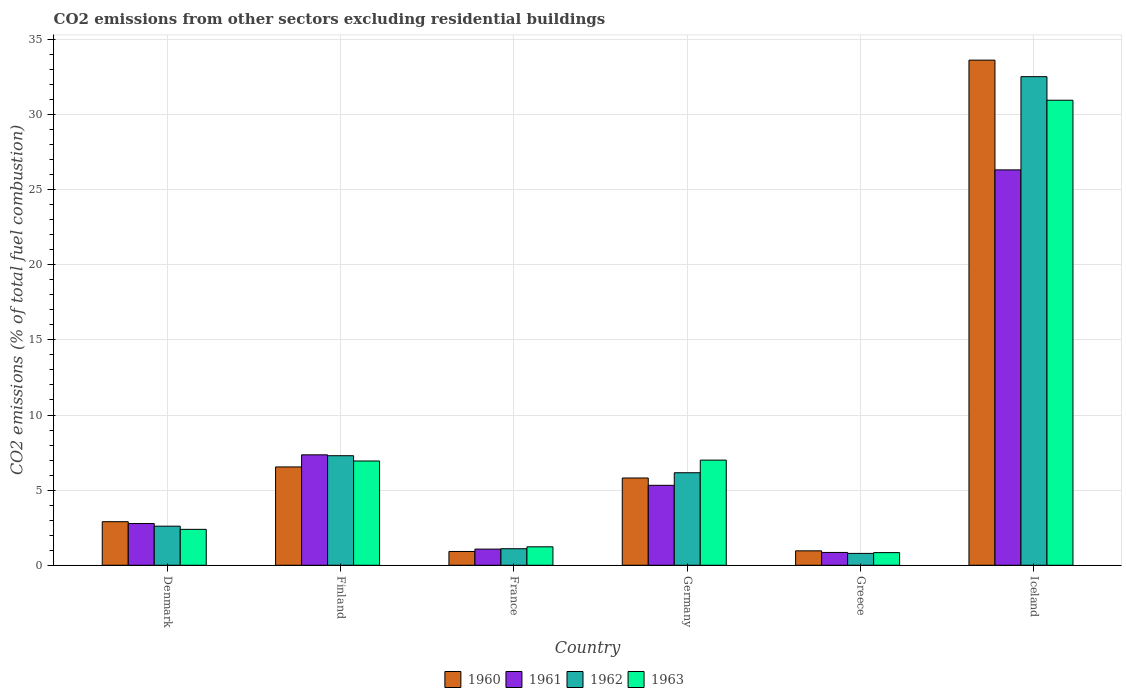How many different coloured bars are there?
Your answer should be very brief. 4. How many groups of bars are there?
Keep it short and to the point. 6. Are the number of bars on each tick of the X-axis equal?
Provide a succinct answer. Yes. How many bars are there on the 1st tick from the right?
Ensure brevity in your answer.  4. In how many cases, is the number of bars for a given country not equal to the number of legend labels?
Your response must be concise. 0. What is the total CO2 emitted in 1960 in Iceland?
Provide a succinct answer. 33.62. Across all countries, what is the maximum total CO2 emitted in 1961?
Make the answer very short. 26.32. Across all countries, what is the minimum total CO2 emitted in 1961?
Ensure brevity in your answer.  0.85. What is the total total CO2 emitted in 1963 in the graph?
Make the answer very short. 49.35. What is the difference between the total CO2 emitted in 1961 in Greece and that in Iceland?
Offer a terse response. -25.46. What is the difference between the total CO2 emitted in 1963 in Iceland and the total CO2 emitted in 1962 in Germany?
Give a very brief answer. 24.79. What is the average total CO2 emitted in 1961 per country?
Offer a terse response. 7.28. What is the difference between the total CO2 emitted of/in 1961 and total CO2 emitted of/in 1963 in France?
Ensure brevity in your answer.  -0.15. In how many countries, is the total CO2 emitted in 1961 greater than 1?
Your response must be concise. 5. What is the ratio of the total CO2 emitted in 1963 in Germany to that in Greece?
Provide a short and direct response. 8.32. Is the total CO2 emitted in 1962 in Germany less than that in Greece?
Offer a terse response. No. Is the difference between the total CO2 emitted in 1961 in Denmark and Finland greater than the difference between the total CO2 emitted in 1963 in Denmark and Finland?
Your answer should be very brief. No. What is the difference between the highest and the second highest total CO2 emitted in 1963?
Your response must be concise. -24.01. What is the difference between the highest and the lowest total CO2 emitted in 1963?
Provide a succinct answer. 30.11. Is it the case that in every country, the sum of the total CO2 emitted in 1961 and total CO2 emitted in 1960 is greater than the total CO2 emitted in 1962?
Ensure brevity in your answer.  Yes. Are all the bars in the graph horizontal?
Provide a short and direct response. No. How many countries are there in the graph?
Ensure brevity in your answer.  6. What is the difference between two consecutive major ticks on the Y-axis?
Your response must be concise. 5. Are the values on the major ticks of Y-axis written in scientific E-notation?
Keep it short and to the point. No. Does the graph contain grids?
Give a very brief answer. Yes. How are the legend labels stacked?
Your response must be concise. Horizontal. What is the title of the graph?
Keep it short and to the point. CO2 emissions from other sectors excluding residential buildings. What is the label or title of the X-axis?
Give a very brief answer. Country. What is the label or title of the Y-axis?
Make the answer very short. CO2 emissions (% of total fuel combustion). What is the CO2 emissions (% of total fuel combustion) of 1960 in Denmark?
Provide a succinct answer. 2.9. What is the CO2 emissions (% of total fuel combustion) in 1961 in Denmark?
Offer a terse response. 2.78. What is the CO2 emissions (% of total fuel combustion) in 1962 in Denmark?
Provide a short and direct response. 2.6. What is the CO2 emissions (% of total fuel combustion) of 1963 in Denmark?
Ensure brevity in your answer.  2.39. What is the CO2 emissions (% of total fuel combustion) in 1960 in Finland?
Provide a short and direct response. 6.54. What is the CO2 emissions (% of total fuel combustion) of 1961 in Finland?
Offer a terse response. 7.35. What is the CO2 emissions (% of total fuel combustion) of 1962 in Finland?
Offer a very short reply. 7.29. What is the CO2 emissions (% of total fuel combustion) in 1963 in Finland?
Your response must be concise. 6.94. What is the CO2 emissions (% of total fuel combustion) of 1960 in France?
Offer a terse response. 0.92. What is the CO2 emissions (% of total fuel combustion) in 1961 in France?
Provide a short and direct response. 1.08. What is the CO2 emissions (% of total fuel combustion) in 1962 in France?
Offer a terse response. 1.1. What is the CO2 emissions (% of total fuel combustion) in 1963 in France?
Your response must be concise. 1.23. What is the CO2 emissions (% of total fuel combustion) of 1960 in Germany?
Offer a terse response. 5.81. What is the CO2 emissions (% of total fuel combustion) in 1961 in Germany?
Ensure brevity in your answer.  5.32. What is the CO2 emissions (% of total fuel combustion) in 1962 in Germany?
Provide a succinct answer. 6.16. What is the CO2 emissions (% of total fuel combustion) of 1963 in Germany?
Your answer should be compact. 7. What is the CO2 emissions (% of total fuel combustion) in 1960 in Greece?
Provide a short and direct response. 0.96. What is the CO2 emissions (% of total fuel combustion) of 1961 in Greece?
Make the answer very short. 0.85. What is the CO2 emissions (% of total fuel combustion) of 1962 in Greece?
Your answer should be very brief. 0.79. What is the CO2 emissions (% of total fuel combustion) in 1963 in Greece?
Your answer should be compact. 0.84. What is the CO2 emissions (% of total fuel combustion) in 1960 in Iceland?
Your answer should be compact. 33.62. What is the CO2 emissions (% of total fuel combustion) in 1961 in Iceland?
Offer a very short reply. 26.32. What is the CO2 emissions (% of total fuel combustion) in 1962 in Iceland?
Provide a succinct answer. 32.52. What is the CO2 emissions (% of total fuel combustion) of 1963 in Iceland?
Your answer should be compact. 30.95. Across all countries, what is the maximum CO2 emissions (% of total fuel combustion) in 1960?
Provide a short and direct response. 33.62. Across all countries, what is the maximum CO2 emissions (% of total fuel combustion) in 1961?
Your response must be concise. 26.32. Across all countries, what is the maximum CO2 emissions (% of total fuel combustion) in 1962?
Make the answer very short. 32.52. Across all countries, what is the maximum CO2 emissions (% of total fuel combustion) in 1963?
Ensure brevity in your answer.  30.95. Across all countries, what is the minimum CO2 emissions (% of total fuel combustion) of 1960?
Ensure brevity in your answer.  0.92. Across all countries, what is the minimum CO2 emissions (% of total fuel combustion) in 1961?
Provide a short and direct response. 0.85. Across all countries, what is the minimum CO2 emissions (% of total fuel combustion) in 1962?
Ensure brevity in your answer.  0.79. Across all countries, what is the minimum CO2 emissions (% of total fuel combustion) of 1963?
Provide a succinct answer. 0.84. What is the total CO2 emissions (% of total fuel combustion) of 1960 in the graph?
Offer a very short reply. 50.75. What is the total CO2 emissions (% of total fuel combustion) in 1961 in the graph?
Provide a short and direct response. 43.69. What is the total CO2 emissions (% of total fuel combustion) of 1962 in the graph?
Give a very brief answer. 50.46. What is the total CO2 emissions (% of total fuel combustion) in 1963 in the graph?
Make the answer very short. 49.35. What is the difference between the CO2 emissions (% of total fuel combustion) in 1960 in Denmark and that in Finland?
Offer a very short reply. -3.64. What is the difference between the CO2 emissions (% of total fuel combustion) of 1961 in Denmark and that in Finland?
Your answer should be compact. -4.57. What is the difference between the CO2 emissions (% of total fuel combustion) of 1962 in Denmark and that in Finland?
Offer a terse response. -4.69. What is the difference between the CO2 emissions (% of total fuel combustion) of 1963 in Denmark and that in Finland?
Ensure brevity in your answer.  -4.55. What is the difference between the CO2 emissions (% of total fuel combustion) of 1960 in Denmark and that in France?
Provide a succinct answer. 1.98. What is the difference between the CO2 emissions (% of total fuel combustion) of 1961 in Denmark and that in France?
Provide a succinct answer. 1.7. What is the difference between the CO2 emissions (% of total fuel combustion) of 1962 in Denmark and that in France?
Ensure brevity in your answer.  1.5. What is the difference between the CO2 emissions (% of total fuel combustion) of 1963 in Denmark and that in France?
Offer a very short reply. 1.16. What is the difference between the CO2 emissions (% of total fuel combustion) in 1960 in Denmark and that in Germany?
Provide a succinct answer. -2.91. What is the difference between the CO2 emissions (% of total fuel combustion) of 1961 in Denmark and that in Germany?
Offer a terse response. -2.54. What is the difference between the CO2 emissions (% of total fuel combustion) of 1962 in Denmark and that in Germany?
Provide a succinct answer. -3.56. What is the difference between the CO2 emissions (% of total fuel combustion) of 1963 in Denmark and that in Germany?
Make the answer very short. -4.61. What is the difference between the CO2 emissions (% of total fuel combustion) of 1960 in Denmark and that in Greece?
Offer a terse response. 1.94. What is the difference between the CO2 emissions (% of total fuel combustion) of 1961 in Denmark and that in Greece?
Ensure brevity in your answer.  1.92. What is the difference between the CO2 emissions (% of total fuel combustion) of 1962 in Denmark and that in Greece?
Ensure brevity in your answer.  1.81. What is the difference between the CO2 emissions (% of total fuel combustion) of 1963 in Denmark and that in Greece?
Keep it short and to the point. 1.55. What is the difference between the CO2 emissions (% of total fuel combustion) of 1960 in Denmark and that in Iceland?
Your answer should be compact. -30.72. What is the difference between the CO2 emissions (% of total fuel combustion) of 1961 in Denmark and that in Iceland?
Give a very brief answer. -23.54. What is the difference between the CO2 emissions (% of total fuel combustion) of 1962 in Denmark and that in Iceland?
Keep it short and to the point. -29.92. What is the difference between the CO2 emissions (% of total fuel combustion) of 1963 in Denmark and that in Iceland?
Provide a succinct answer. -28.56. What is the difference between the CO2 emissions (% of total fuel combustion) of 1960 in Finland and that in France?
Your response must be concise. 5.63. What is the difference between the CO2 emissions (% of total fuel combustion) of 1961 in Finland and that in France?
Make the answer very short. 6.27. What is the difference between the CO2 emissions (% of total fuel combustion) of 1962 in Finland and that in France?
Your answer should be compact. 6.19. What is the difference between the CO2 emissions (% of total fuel combustion) in 1963 in Finland and that in France?
Provide a succinct answer. 5.71. What is the difference between the CO2 emissions (% of total fuel combustion) of 1960 in Finland and that in Germany?
Ensure brevity in your answer.  0.74. What is the difference between the CO2 emissions (% of total fuel combustion) of 1961 in Finland and that in Germany?
Give a very brief answer. 2.03. What is the difference between the CO2 emissions (% of total fuel combustion) in 1962 in Finland and that in Germany?
Offer a very short reply. 1.13. What is the difference between the CO2 emissions (% of total fuel combustion) of 1963 in Finland and that in Germany?
Give a very brief answer. -0.06. What is the difference between the CO2 emissions (% of total fuel combustion) in 1960 in Finland and that in Greece?
Provide a short and direct response. 5.58. What is the difference between the CO2 emissions (% of total fuel combustion) in 1961 in Finland and that in Greece?
Ensure brevity in your answer.  6.5. What is the difference between the CO2 emissions (% of total fuel combustion) in 1962 in Finland and that in Greece?
Provide a succinct answer. 6.5. What is the difference between the CO2 emissions (% of total fuel combustion) in 1963 in Finland and that in Greece?
Offer a very short reply. 6.1. What is the difference between the CO2 emissions (% of total fuel combustion) in 1960 in Finland and that in Iceland?
Your answer should be compact. -27.08. What is the difference between the CO2 emissions (% of total fuel combustion) of 1961 in Finland and that in Iceland?
Provide a short and direct response. -18.97. What is the difference between the CO2 emissions (% of total fuel combustion) of 1962 in Finland and that in Iceland?
Offer a terse response. -25.23. What is the difference between the CO2 emissions (% of total fuel combustion) of 1963 in Finland and that in Iceland?
Your answer should be very brief. -24.01. What is the difference between the CO2 emissions (% of total fuel combustion) in 1960 in France and that in Germany?
Offer a terse response. -4.89. What is the difference between the CO2 emissions (% of total fuel combustion) of 1961 in France and that in Germany?
Your response must be concise. -4.25. What is the difference between the CO2 emissions (% of total fuel combustion) in 1962 in France and that in Germany?
Ensure brevity in your answer.  -5.06. What is the difference between the CO2 emissions (% of total fuel combustion) of 1963 in France and that in Germany?
Provide a short and direct response. -5.77. What is the difference between the CO2 emissions (% of total fuel combustion) in 1960 in France and that in Greece?
Your response must be concise. -0.04. What is the difference between the CO2 emissions (% of total fuel combustion) of 1961 in France and that in Greece?
Provide a succinct answer. 0.22. What is the difference between the CO2 emissions (% of total fuel combustion) of 1962 in France and that in Greece?
Offer a very short reply. 0.31. What is the difference between the CO2 emissions (% of total fuel combustion) in 1963 in France and that in Greece?
Give a very brief answer. 0.39. What is the difference between the CO2 emissions (% of total fuel combustion) of 1960 in France and that in Iceland?
Give a very brief answer. -32.7. What is the difference between the CO2 emissions (% of total fuel combustion) in 1961 in France and that in Iceland?
Provide a succinct answer. -25.24. What is the difference between the CO2 emissions (% of total fuel combustion) of 1962 in France and that in Iceland?
Your answer should be very brief. -31.42. What is the difference between the CO2 emissions (% of total fuel combustion) in 1963 in France and that in Iceland?
Your answer should be compact. -29.73. What is the difference between the CO2 emissions (% of total fuel combustion) in 1960 in Germany and that in Greece?
Give a very brief answer. 4.85. What is the difference between the CO2 emissions (% of total fuel combustion) in 1961 in Germany and that in Greece?
Your answer should be very brief. 4.47. What is the difference between the CO2 emissions (% of total fuel combustion) of 1962 in Germany and that in Greece?
Your answer should be very brief. 5.37. What is the difference between the CO2 emissions (% of total fuel combustion) in 1963 in Germany and that in Greece?
Offer a terse response. 6.16. What is the difference between the CO2 emissions (% of total fuel combustion) of 1960 in Germany and that in Iceland?
Your response must be concise. -27.81. What is the difference between the CO2 emissions (% of total fuel combustion) of 1961 in Germany and that in Iceland?
Make the answer very short. -20.99. What is the difference between the CO2 emissions (% of total fuel combustion) in 1962 in Germany and that in Iceland?
Give a very brief answer. -26.36. What is the difference between the CO2 emissions (% of total fuel combustion) in 1963 in Germany and that in Iceland?
Keep it short and to the point. -23.95. What is the difference between the CO2 emissions (% of total fuel combustion) of 1960 in Greece and that in Iceland?
Keep it short and to the point. -32.66. What is the difference between the CO2 emissions (% of total fuel combustion) of 1961 in Greece and that in Iceland?
Offer a terse response. -25.46. What is the difference between the CO2 emissions (% of total fuel combustion) in 1962 in Greece and that in Iceland?
Provide a succinct answer. -31.73. What is the difference between the CO2 emissions (% of total fuel combustion) in 1963 in Greece and that in Iceland?
Your response must be concise. -30.11. What is the difference between the CO2 emissions (% of total fuel combustion) of 1960 in Denmark and the CO2 emissions (% of total fuel combustion) of 1961 in Finland?
Provide a short and direct response. -4.45. What is the difference between the CO2 emissions (% of total fuel combustion) of 1960 in Denmark and the CO2 emissions (% of total fuel combustion) of 1962 in Finland?
Your answer should be very brief. -4.39. What is the difference between the CO2 emissions (% of total fuel combustion) in 1960 in Denmark and the CO2 emissions (% of total fuel combustion) in 1963 in Finland?
Provide a succinct answer. -4.04. What is the difference between the CO2 emissions (% of total fuel combustion) in 1961 in Denmark and the CO2 emissions (% of total fuel combustion) in 1962 in Finland?
Provide a succinct answer. -4.51. What is the difference between the CO2 emissions (% of total fuel combustion) in 1961 in Denmark and the CO2 emissions (% of total fuel combustion) in 1963 in Finland?
Your answer should be compact. -4.16. What is the difference between the CO2 emissions (% of total fuel combustion) of 1962 in Denmark and the CO2 emissions (% of total fuel combustion) of 1963 in Finland?
Give a very brief answer. -4.34. What is the difference between the CO2 emissions (% of total fuel combustion) in 1960 in Denmark and the CO2 emissions (% of total fuel combustion) in 1961 in France?
Ensure brevity in your answer.  1.82. What is the difference between the CO2 emissions (% of total fuel combustion) in 1960 in Denmark and the CO2 emissions (% of total fuel combustion) in 1962 in France?
Ensure brevity in your answer.  1.8. What is the difference between the CO2 emissions (% of total fuel combustion) in 1960 in Denmark and the CO2 emissions (% of total fuel combustion) in 1963 in France?
Provide a short and direct response. 1.67. What is the difference between the CO2 emissions (% of total fuel combustion) of 1961 in Denmark and the CO2 emissions (% of total fuel combustion) of 1962 in France?
Your response must be concise. 1.68. What is the difference between the CO2 emissions (% of total fuel combustion) of 1961 in Denmark and the CO2 emissions (% of total fuel combustion) of 1963 in France?
Make the answer very short. 1.55. What is the difference between the CO2 emissions (% of total fuel combustion) of 1962 in Denmark and the CO2 emissions (% of total fuel combustion) of 1963 in France?
Your response must be concise. 1.37. What is the difference between the CO2 emissions (% of total fuel combustion) in 1960 in Denmark and the CO2 emissions (% of total fuel combustion) in 1961 in Germany?
Make the answer very short. -2.42. What is the difference between the CO2 emissions (% of total fuel combustion) in 1960 in Denmark and the CO2 emissions (% of total fuel combustion) in 1962 in Germany?
Your response must be concise. -3.26. What is the difference between the CO2 emissions (% of total fuel combustion) in 1960 in Denmark and the CO2 emissions (% of total fuel combustion) in 1963 in Germany?
Your answer should be compact. -4.1. What is the difference between the CO2 emissions (% of total fuel combustion) of 1961 in Denmark and the CO2 emissions (% of total fuel combustion) of 1962 in Germany?
Your answer should be very brief. -3.38. What is the difference between the CO2 emissions (% of total fuel combustion) in 1961 in Denmark and the CO2 emissions (% of total fuel combustion) in 1963 in Germany?
Provide a short and direct response. -4.22. What is the difference between the CO2 emissions (% of total fuel combustion) in 1962 in Denmark and the CO2 emissions (% of total fuel combustion) in 1963 in Germany?
Offer a very short reply. -4.4. What is the difference between the CO2 emissions (% of total fuel combustion) in 1960 in Denmark and the CO2 emissions (% of total fuel combustion) in 1961 in Greece?
Your answer should be compact. 2.05. What is the difference between the CO2 emissions (% of total fuel combustion) in 1960 in Denmark and the CO2 emissions (% of total fuel combustion) in 1962 in Greece?
Your answer should be very brief. 2.11. What is the difference between the CO2 emissions (% of total fuel combustion) of 1960 in Denmark and the CO2 emissions (% of total fuel combustion) of 1963 in Greece?
Offer a very short reply. 2.06. What is the difference between the CO2 emissions (% of total fuel combustion) in 1961 in Denmark and the CO2 emissions (% of total fuel combustion) in 1962 in Greece?
Provide a succinct answer. 1.99. What is the difference between the CO2 emissions (% of total fuel combustion) of 1961 in Denmark and the CO2 emissions (% of total fuel combustion) of 1963 in Greece?
Your response must be concise. 1.94. What is the difference between the CO2 emissions (% of total fuel combustion) in 1962 in Denmark and the CO2 emissions (% of total fuel combustion) in 1963 in Greece?
Provide a succinct answer. 1.76. What is the difference between the CO2 emissions (% of total fuel combustion) in 1960 in Denmark and the CO2 emissions (% of total fuel combustion) in 1961 in Iceland?
Your response must be concise. -23.42. What is the difference between the CO2 emissions (% of total fuel combustion) of 1960 in Denmark and the CO2 emissions (% of total fuel combustion) of 1962 in Iceland?
Keep it short and to the point. -29.62. What is the difference between the CO2 emissions (% of total fuel combustion) in 1960 in Denmark and the CO2 emissions (% of total fuel combustion) in 1963 in Iceland?
Provide a succinct answer. -28.05. What is the difference between the CO2 emissions (% of total fuel combustion) of 1961 in Denmark and the CO2 emissions (% of total fuel combustion) of 1962 in Iceland?
Provide a succinct answer. -29.74. What is the difference between the CO2 emissions (% of total fuel combustion) of 1961 in Denmark and the CO2 emissions (% of total fuel combustion) of 1963 in Iceland?
Provide a succinct answer. -28.18. What is the difference between the CO2 emissions (% of total fuel combustion) in 1962 in Denmark and the CO2 emissions (% of total fuel combustion) in 1963 in Iceland?
Ensure brevity in your answer.  -28.35. What is the difference between the CO2 emissions (% of total fuel combustion) of 1960 in Finland and the CO2 emissions (% of total fuel combustion) of 1961 in France?
Keep it short and to the point. 5.47. What is the difference between the CO2 emissions (% of total fuel combustion) in 1960 in Finland and the CO2 emissions (% of total fuel combustion) in 1962 in France?
Your response must be concise. 5.44. What is the difference between the CO2 emissions (% of total fuel combustion) in 1960 in Finland and the CO2 emissions (% of total fuel combustion) in 1963 in France?
Offer a very short reply. 5.32. What is the difference between the CO2 emissions (% of total fuel combustion) in 1961 in Finland and the CO2 emissions (% of total fuel combustion) in 1962 in France?
Your answer should be very brief. 6.25. What is the difference between the CO2 emissions (% of total fuel combustion) in 1961 in Finland and the CO2 emissions (% of total fuel combustion) in 1963 in France?
Ensure brevity in your answer.  6.12. What is the difference between the CO2 emissions (% of total fuel combustion) of 1962 in Finland and the CO2 emissions (% of total fuel combustion) of 1963 in France?
Your response must be concise. 6.06. What is the difference between the CO2 emissions (% of total fuel combustion) of 1960 in Finland and the CO2 emissions (% of total fuel combustion) of 1961 in Germany?
Give a very brief answer. 1.22. What is the difference between the CO2 emissions (% of total fuel combustion) in 1960 in Finland and the CO2 emissions (% of total fuel combustion) in 1962 in Germany?
Your response must be concise. 0.39. What is the difference between the CO2 emissions (% of total fuel combustion) in 1960 in Finland and the CO2 emissions (% of total fuel combustion) in 1963 in Germany?
Give a very brief answer. -0.45. What is the difference between the CO2 emissions (% of total fuel combustion) in 1961 in Finland and the CO2 emissions (% of total fuel combustion) in 1962 in Germany?
Offer a very short reply. 1.19. What is the difference between the CO2 emissions (% of total fuel combustion) of 1961 in Finland and the CO2 emissions (% of total fuel combustion) of 1963 in Germany?
Your answer should be compact. 0.35. What is the difference between the CO2 emissions (% of total fuel combustion) in 1962 in Finland and the CO2 emissions (% of total fuel combustion) in 1963 in Germany?
Your answer should be compact. 0.29. What is the difference between the CO2 emissions (% of total fuel combustion) of 1960 in Finland and the CO2 emissions (% of total fuel combustion) of 1961 in Greece?
Keep it short and to the point. 5.69. What is the difference between the CO2 emissions (% of total fuel combustion) in 1960 in Finland and the CO2 emissions (% of total fuel combustion) in 1962 in Greece?
Provide a short and direct response. 5.76. What is the difference between the CO2 emissions (% of total fuel combustion) in 1960 in Finland and the CO2 emissions (% of total fuel combustion) in 1963 in Greece?
Your answer should be very brief. 5.7. What is the difference between the CO2 emissions (% of total fuel combustion) in 1961 in Finland and the CO2 emissions (% of total fuel combustion) in 1962 in Greece?
Offer a terse response. 6.56. What is the difference between the CO2 emissions (% of total fuel combustion) in 1961 in Finland and the CO2 emissions (% of total fuel combustion) in 1963 in Greece?
Your answer should be compact. 6.51. What is the difference between the CO2 emissions (% of total fuel combustion) in 1962 in Finland and the CO2 emissions (% of total fuel combustion) in 1963 in Greece?
Ensure brevity in your answer.  6.45. What is the difference between the CO2 emissions (% of total fuel combustion) of 1960 in Finland and the CO2 emissions (% of total fuel combustion) of 1961 in Iceland?
Your answer should be compact. -19.77. What is the difference between the CO2 emissions (% of total fuel combustion) in 1960 in Finland and the CO2 emissions (% of total fuel combustion) in 1962 in Iceland?
Ensure brevity in your answer.  -25.98. What is the difference between the CO2 emissions (% of total fuel combustion) in 1960 in Finland and the CO2 emissions (% of total fuel combustion) in 1963 in Iceland?
Offer a terse response. -24.41. What is the difference between the CO2 emissions (% of total fuel combustion) of 1961 in Finland and the CO2 emissions (% of total fuel combustion) of 1962 in Iceland?
Make the answer very short. -25.17. What is the difference between the CO2 emissions (% of total fuel combustion) of 1961 in Finland and the CO2 emissions (% of total fuel combustion) of 1963 in Iceland?
Provide a short and direct response. -23.6. What is the difference between the CO2 emissions (% of total fuel combustion) of 1962 in Finland and the CO2 emissions (% of total fuel combustion) of 1963 in Iceland?
Your answer should be very brief. -23.66. What is the difference between the CO2 emissions (% of total fuel combustion) in 1960 in France and the CO2 emissions (% of total fuel combustion) in 1961 in Germany?
Offer a terse response. -4.4. What is the difference between the CO2 emissions (% of total fuel combustion) in 1960 in France and the CO2 emissions (% of total fuel combustion) in 1962 in Germany?
Provide a short and direct response. -5.24. What is the difference between the CO2 emissions (% of total fuel combustion) of 1960 in France and the CO2 emissions (% of total fuel combustion) of 1963 in Germany?
Make the answer very short. -6.08. What is the difference between the CO2 emissions (% of total fuel combustion) in 1961 in France and the CO2 emissions (% of total fuel combustion) in 1962 in Germany?
Offer a very short reply. -5.08. What is the difference between the CO2 emissions (% of total fuel combustion) in 1961 in France and the CO2 emissions (% of total fuel combustion) in 1963 in Germany?
Provide a succinct answer. -5.92. What is the difference between the CO2 emissions (% of total fuel combustion) of 1962 in France and the CO2 emissions (% of total fuel combustion) of 1963 in Germany?
Provide a short and direct response. -5.9. What is the difference between the CO2 emissions (% of total fuel combustion) of 1960 in France and the CO2 emissions (% of total fuel combustion) of 1961 in Greece?
Your answer should be very brief. 0.06. What is the difference between the CO2 emissions (% of total fuel combustion) of 1960 in France and the CO2 emissions (% of total fuel combustion) of 1962 in Greece?
Your response must be concise. 0.13. What is the difference between the CO2 emissions (% of total fuel combustion) of 1960 in France and the CO2 emissions (% of total fuel combustion) of 1963 in Greece?
Ensure brevity in your answer.  0.08. What is the difference between the CO2 emissions (% of total fuel combustion) of 1961 in France and the CO2 emissions (% of total fuel combustion) of 1962 in Greece?
Provide a short and direct response. 0.29. What is the difference between the CO2 emissions (% of total fuel combustion) in 1961 in France and the CO2 emissions (% of total fuel combustion) in 1963 in Greece?
Keep it short and to the point. 0.23. What is the difference between the CO2 emissions (% of total fuel combustion) in 1962 in France and the CO2 emissions (% of total fuel combustion) in 1963 in Greece?
Keep it short and to the point. 0.26. What is the difference between the CO2 emissions (% of total fuel combustion) in 1960 in France and the CO2 emissions (% of total fuel combustion) in 1961 in Iceland?
Keep it short and to the point. -25.4. What is the difference between the CO2 emissions (% of total fuel combustion) of 1960 in France and the CO2 emissions (% of total fuel combustion) of 1962 in Iceland?
Your answer should be very brief. -31.6. What is the difference between the CO2 emissions (% of total fuel combustion) in 1960 in France and the CO2 emissions (% of total fuel combustion) in 1963 in Iceland?
Offer a very short reply. -30.04. What is the difference between the CO2 emissions (% of total fuel combustion) in 1961 in France and the CO2 emissions (% of total fuel combustion) in 1962 in Iceland?
Provide a succinct answer. -31.44. What is the difference between the CO2 emissions (% of total fuel combustion) of 1961 in France and the CO2 emissions (% of total fuel combustion) of 1963 in Iceland?
Offer a very short reply. -29.88. What is the difference between the CO2 emissions (% of total fuel combustion) of 1962 in France and the CO2 emissions (% of total fuel combustion) of 1963 in Iceland?
Provide a succinct answer. -29.85. What is the difference between the CO2 emissions (% of total fuel combustion) of 1960 in Germany and the CO2 emissions (% of total fuel combustion) of 1961 in Greece?
Offer a terse response. 4.96. What is the difference between the CO2 emissions (% of total fuel combustion) in 1960 in Germany and the CO2 emissions (% of total fuel combustion) in 1962 in Greece?
Ensure brevity in your answer.  5.02. What is the difference between the CO2 emissions (% of total fuel combustion) of 1960 in Germany and the CO2 emissions (% of total fuel combustion) of 1963 in Greece?
Give a very brief answer. 4.97. What is the difference between the CO2 emissions (% of total fuel combustion) of 1961 in Germany and the CO2 emissions (% of total fuel combustion) of 1962 in Greece?
Your answer should be very brief. 4.53. What is the difference between the CO2 emissions (% of total fuel combustion) of 1961 in Germany and the CO2 emissions (% of total fuel combustion) of 1963 in Greece?
Your answer should be compact. 4.48. What is the difference between the CO2 emissions (% of total fuel combustion) in 1962 in Germany and the CO2 emissions (% of total fuel combustion) in 1963 in Greece?
Provide a succinct answer. 5.32. What is the difference between the CO2 emissions (% of total fuel combustion) in 1960 in Germany and the CO2 emissions (% of total fuel combustion) in 1961 in Iceland?
Keep it short and to the point. -20.51. What is the difference between the CO2 emissions (% of total fuel combustion) of 1960 in Germany and the CO2 emissions (% of total fuel combustion) of 1962 in Iceland?
Your response must be concise. -26.71. What is the difference between the CO2 emissions (% of total fuel combustion) of 1960 in Germany and the CO2 emissions (% of total fuel combustion) of 1963 in Iceland?
Your answer should be very brief. -25.14. What is the difference between the CO2 emissions (% of total fuel combustion) of 1961 in Germany and the CO2 emissions (% of total fuel combustion) of 1962 in Iceland?
Ensure brevity in your answer.  -27.2. What is the difference between the CO2 emissions (% of total fuel combustion) of 1961 in Germany and the CO2 emissions (% of total fuel combustion) of 1963 in Iceland?
Offer a terse response. -25.63. What is the difference between the CO2 emissions (% of total fuel combustion) in 1962 in Germany and the CO2 emissions (% of total fuel combustion) in 1963 in Iceland?
Keep it short and to the point. -24.79. What is the difference between the CO2 emissions (% of total fuel combustion) in 1960 in Greece and the CO2 emissions (% of total fuel combustion) in 1961 in Iceland?
Your answer should be very brief. -25.36. What is the difference between the CO2 emissions (% of total fuel combustion) in 1960 in Greece and the CO2 emissions (% of total fuel combustion) in 1962 in Iceland?
Your answer should be compact. -31.56. What is the difference between the CO2 emissions (% of total fuel combustion) in 1960 in Greece and the CO2 emissions (% of total fuel combustion) in 1963 in Iceland?
Provide a short and direct response. -29.99. What is the difference between the CO2 emissions (% of total fuel combustion) of 1961 in Greece and the CO2 emissions (% of total fuel combustion) of 1962 in Iceland?
Make the answer very short. -31.67. What is the difference between the CO2 emissions (% of total fuel combustion) in 1961 in Greece and the CO2 emissions (% of total fuel combustion) in 1963 in Iceland?
Your answer should be compact. -30.1. What is the difference between the CO2 emissions (% of total fuel combustion) in 1962 in Greece and the CO2 emissions (% of total fuel combustion) in 1963 in Iceland?
Your answer should be very brief. -30.16. What is the average CO2 emissions (% of total fuel combustion) of 1960 per country?
Make the answer very short. 8.46. What is the average CO2 emissions (% of total fuel combustion) in 1961 per country?
Ensure brevity in your answer.  7.28. What is the average CO2 emissions (% of total fuel combustion) in 1962 per country?
Ensure brevity in your answer.  8.41. What is the average CO2 emissions (% of total fuel combustion) in 1963 per country?
Your answer should be compact. 8.22. What is the difference between the CO2 emissions (% of total fuel combustion) in 1960 and CO2 emissions (% of total fuel combustion) in 1961 in Denmark?
Your answer should be compact. 0.12. What is the difference between the CO2 emissions (% of total fuel combustion) of 1960 and CO2 emissions (% of total fuel combustion) of 1962 in Denmark?
Keep it short and to the point. 0.3. What is the difference between the CO2 emissions (% of total fuel combustion) in 1960 and CO2 emissions (% of total fuel combustion) in 1963 in Denmark?
Provide a succinct answer. 0.51. What is the difference between the CO2 emissions (% of total fuel combustion) of 1961 and CO2 emissions (% of total fuel combustion) of 1962 in Denmark?
Your answer should be compact. 0.18. What is the difference between the CO2 emissions (% of total fuel combustion) in 1961 and CO2 emissions (% of total fuel combustion) in 1963 in Denmark?
Provide a short and direct response. 0.39. What is the difference between the CO2 emissions (% of total fuel combustion) of 1962 and CO2 emissions (% of total fuel combustion) of 1963 in Denmark?
Keep it short and to the point. 0.21. What is the difference between the CO2 emissions (% of total fuel combustion) in 1960 and CO2 emissions (% of total fuel combustion) in 1961 in Finland?
Offer a terse response. -0.81. What is the difference between the CO2 emissions (% of total fuel combustion) in 1960 and CO2 emissions (% of total fuel combustion) in 1962 in Finland?
Provide a succinct answer. -0.75. What is the difference between the CO2 emissions (% of total fuel combustion) in 1960 and CO2 emissions (% of total fuel combustion) in 1963 in Finland?
Your response must be concise. -0.4. What is the difference between the CO2 emissions (% of total fuel combustion) of 1961 and CO2 emissions (% of total fuel combustion) of 1962 in Finland?
Your answer should be very brief. 0.06. What is the difference between the CO2 emissions (% of total fuel combustion) of 1961 and CO2 emissions (% of total fuel combustion) of 1963 in Finland?
Your response must be concise. 0.41. What is the difference between the CO2 emissions (% of total fuel combustion) in 1962 and CO2 emissions (% of total fuel combustion) in 1963 in Finland?
Keep it short and to the point. 0.35. What is the difference between the CO2 emissions (% of total fuel combustion) in 1960 and CO2 emissions (% of total fuel combustion) in 1961 in France?
Your response must be concise. -0.16. What is the difference between the CO2 emissions (% of total fuel combustion) of 1960 and CO2 emissions (% of total fuel combustion) of 1962 in France?
Offer a terse response. -0.18. What is the difference between the CO2 emissions (% of total fuel combustion) in 1960 and CO2 emissions (% of total fuel combustion) in 1963 in France?
Provide a short and direct response. -0.31. What is the difference between the CO2 emissions (% of total fuel combustion) of 1961 and CO2 emissions (% of total fuel combustion) of 1962 in France?
Give a very brief answer. -0.02. What is the difference between the CO2 emissions (% of total fuel combustion) in 1961 and CO2 emissions (% of total fuel combustion) in 1963 in France?
Keep it short and to the point. -0.15. What is the difference between the CO2 emissions (% of total fuel combustion) of 1962 and CO2 emissions (% of total fuel combustion) of 1963 in France?
Keep it short and to the point. -0.13. What is the difference between the CO2 emissions (% of total fuel combustion) of 1960 and CO2 emissions (% of total fuel combustion) of 1961 in Germany?
Provide a short and direct response. 0.49. What is the difference between the CO2 emissions (% of total fuel combustion) of 1960 and CO2 emissions (% of total fuel combustion) of 1962 in Germany?
Provide a succinct answer. -0.35. What is the difference between the CO2 emissions (% of total fuel combustion) of 1960 and CO2 emissions (% of total fuel combustion) of 1963 in Germany?
Offer a very short reply. -1.19. What is the difference between the CO2 emissions (% of total fuel combustion) of 1961 and CO2 emissions (% of total fuel combustion) of 1962 in Germany?
Your answer should be very brief. -0.84. What is the difference between the CO2 emissions (% of total fuel combustion) of 1961 and CO2 emissions (% of total fuel combustion) of 1963 in Germany?
Your response must be concise. -1.68. What is the difference between the CO2 emissions (% of total fuel combustion) of 1962 and CO2 emissions (% of total fuel combustion) of 1963 in Germany?
Keep it short and to the point. -0.84. What is the difference between the CO2 emissions (% of total fuel combustion) of 1960 and CO2 emissions (% of total fuel combustion) of 1961 in Greece?
Your answer should be very brief. 0.11. What is the difference between the CO2 emissions (% of total fuel combustion) of 1960 and CO2 emissions (% of total fuel combustion) of 1962 in Greece?
Make the answer very short. 0.17. What is the difference between the CO2 emissions (% of total fuel combustion) of 1960 and CO2 emissions (% of total fuel combustion) of 1963 in Greece?
Make the answer very short. 0.12. What is the difference between the CO2 emissions (% of total fuel combustion) of 1961 and CO2 emissions (% of total fuel combustion) of 1962 in Greece?
Your answer should be very brief. 0.06. What is the difference between the CO2 emissions (% of total fuel combustion) in 1961 and CO2 emissions (% of total fuel combustion) in 1963 in Greece?
Offer a terse response. 0.01. What is the difference between the CO2 emissions (% of total fuel combustion) of 1962 and CO2 emissions (% of total fuel combustion) of 1963 in Greece?
Your response must be concise. -0.05. What is the difference between the CO2 emissions (% of total fuel combustion) of 1960 and CO2 emissions (% of total fuel combustion) of 1961 in Iceland?
Make the answer very short. 7.3. What is the difference between the CO2 emissions (% of total fuel combustion) in 1960 and CO2 emissions (% of total fuel combustion) in 1962 in Iceland?
Make the answer very short. 1.1. What is the difference between the CO2 emissions (% of total fuel combustion) of 1960 and CO2 emissions (% of total fuel combustion) of 1963 in Iceland?
Ensure brevity in your answer.  2.67. What is the difference between the CO2 emissions (% of total fuel combustion) in 1961 and CO2 emissions (% of total fuel combustion) in 1962 in Iceland?
Give a very brief answer. -6.2. What is the difference between the CO2 emissions (% of total fuel combustion) in 1961 and CO2 emissions (% of total fuel combustion) in 1963 in Iceland?
Give a very brief answer. -4.64. What is the difference between the CO2 emissions (% of total fuel combustion) of 1962 and CO2 emissions (% of total fuel combustion) of 1963 in Iceland?
Offer a terse response. 1.57. What is the ratio of the CO2 emissions (% of total fuel combustion) of 1960 in Denmark to that in Finland?
Provide a short and direct response. 0.44. What is the ratio of the CO2 emissions (% of total fuel combustion) of 1961 in Denmark to that in Finland?
Offer a very short reply. 0.38. What is the ratio of the CO2 emissions (% of total fuel combustion) of 1962 in Denmark to that in Finland?
Give a very brief answer. 0.36. What is the ratio of the CO2 emissions (% of total fuel combustion) in 1963 in Denmark to that in Finland?
Keep it short and to the point. 0.34. What is the ratio of the CO2 emissions (% of total fuel combustion) in 1960 in Denmark to that in France?
Give a very brief answer. 3.16. What is the ratio of the CO2 emissions (% of total fuel combustion) of 1961 in Denmark to that in France?
Your response must be concise. 2.58. What is the ratio of the CO2 emissions (% of total fuel combustion) of 1962 in Denmark to that in France?
Provide a short and direct response. 2.36. What is the ratio of the CO2 emissions (% of total fuel combustion) of 1963 in Denmark to that in France?
Offer a terse response. 1.95. What is the ratio of the CO2 emissions (% of total fuel combustion) of 1960 in Denmark to that in Germany?
Your answer should be compact. 0.5. What is the ratio of the CO2 emissions (% of total fuel combustion) in 1961 in Denmark to that in Germany?
Ensure brevity in your answer.  0.52. What is the ratio of the CO2 emissions (% of total fuel combustion) of 1962 in Denmark to that in Germany?
Offer a very short reply. 0.42. What is the ratio of the CO2 emissions (% of total fuel combustion) of 1963 in Denmark to that in Germany?
Your response must be concise. 0.34. What is the ratio of the CO2 emissions (% of total fuel combustion) in 1960 in Denmark to that in Greece?
Your answer should be very brief. 3.02. What is the ratio of the CO2 emissions (% of total fuel combustion) of 1961 in Denmark to that in Greece?
Offer a terse response. 3.26. What is the ratio of the CO2 emissions (% of total fuel combustion) in 1962 in Denmark to that in Greece?
Provide a short and direct response. 3.3. What is the ratio of the CO2 emissions (% of total fuel combustion) in 1963 in Denmark to that in Greece?
Provide a succinct answer. 2.84. What is the ratio of the CO2 emissions (% of total fuel combustion) in 1960 in Denmark to that in Iceland?
Make the answer very short. 0.09. What is the ratio of the CO2 emissions (% of total fuel combustion) in 1961 in Denmark to that in Iceland?
Make the answer very short. 0.11. What is the ratio of the CO2 emissions (% of total fuel combustion) of 1962 in Denmark to that in Iceland?
Make the answer very short. 0.08. What is the ratio of the CO2 emissions (% of total fuel combustion) of 1963 in Denmark to that in Iceland?
Offer a very short reply. 0.08. What is the ratio of the CO2 emissions (% of total fuel combustion) in 1960 in Finland to that in France?
Your answer should be compact. 7.14. What is the ratio of the CO2 emissions (% of total fuel combustion) in 1961 in Finland to that in France?
Offer a very short reply. 6.83. What is the ratio of the CO2 emissions (% of total fuel combustion) of 1962 in Finland to that in France?
Give a very brief answer. 6.63. What is the ratio of the CO2 emissions (% of total fuel combustion) of 1963 in Finland to that in France?
Offer a terse response. 5.66. What is the ratio of the CO2 emissions (% of total fuel combustion) of 1960 in Finland to that in Germany?
Provide a short and direct response. 1.13. What is the ratio of the CO2 emissions (% of total fuel combustion) in 1961 in Finland to that in Germany?
Your answer should be compact. 1.38. What is the ratio of the CO2 emissions (% of total fuel combustion) of 1962 in Finland to that in Germany?
Your answer should be very brief. 1.18. What is the ratio of the CO2 emissions (% of total fuel combustion) in 1963 in Finland to that in Germany?
Offer a very short reply. 0.99. What is the ratio of the CO2 emissions (% of total fuel combustion) of 1960 in Finland to that in Greece?
Provide a succinct answer. 6.82. What is the ratio of the CO2 emissions (% of total fuel combustion) of 1961 in Finland to that in Greece?
Ensure brevity in your answer.  8.62. What is the ratio of the CO2 emissions (% of total fuel combustion) in 1962 in Finland to that in Greece?
Keep it short and to the point. 9.24. What is the ratio of the CO2 emissions (% of total fuel combustion) of 1963 in Finland to that in Greece?
Ensure brevity in your answer.  8.25. What is the ratio of the CO2 emissions (% of total fuel combustion) in 1960 in Finland to that in Iceland?
Provide a succinct answer. 0.19. What is the ratio of the CO2 emissions (% of total fuel combustion) in 1961 in Finland to that in Iceland?
Your response must be concise. 0.28. What is the ratio of the CO2 emissions (% of total fuel combustion) of 1962 in Finland to that in Iceland?
Give a very brief answer. 0.22. What is the ratio of the CO2 emissions (% of total fuel combustion) in 1963 in Finland to that in Iceland?
Provide a succinct answer. 0.22. What is the ratio of the CO2 emissions (% of total fuel combustion) in 1960 in France to that in Germany?
Provide a short and direct response. 0.16. What is the ratio of the CO2 emissions (% of total fuel combustion) of 1961 in France to that in Germany?
Give a very brief answer. 0.2. What is the ratio of the CO2 emissions (% of total fuel combustion) of 1962 in France to that in Germany?
Your answer should be very brief. 0.18. What is the ratio of the CO2 emissions (% of total fuel combustion) of 1963 in France to that in Germany?
Your answer should be very brief. 0.18. What is the ratio of the CO2 emissions (% of total fuel combustion) of 1960 in France to that in Greece?
Your answer should be very brief. 0.96. What is the ratio of the CO2 emissions (% of total fuel combustion) in 1961 in France to that in Greece?
Ensure brevity in your answer.  1.26. What is the ratio of the CO2 emissions (% of total fuel combustion) in 1962 in France to that in Greece?
Give a very brief answer. 1.39. What is the ratio of the CO2 emissions (% of total fuel combustion) in 1963 in France to that in Greece?
Make the answer very short. 1.46. What is the ratio of the CO2 emissions (% of total fuel combustion) in 1960 in France to that in Iceland?
Give a very brief answer. 0.03. What is the ratio of the CO2 emissions (% of total fuel combustion) of 1961 in France to that in Iceland?
Your answer should be very brief. 0.04. What is the ratio of the CO2 emissions (% of total fuel combustion) in 1962 in France to that in Iceland?
Offer a terse response. 0.03. What is the ratio of the CO2 emissions (% of total fuel combustion) of 1963 in France to that in Iceland?
Give a very brief answer. 0.04. What is the ratio of the CO2 emissions (% of total fuel combustion) in 1960 in Germany to that in Greece?
Ensure brevity in your answer.  6.05. What is the ratio of the CO2 emissions (% of total fuel combustion) of 1961 in Germany to that in Greece?
Give a very brief answer. 6.24. What is the ratio of the CO2 emissions (% of total fuel combustion) in 1962 in Germany to that in Greece?
Give a very brief answer. 7.8. What is the ratio of the CO2 emissions (% of total fuel combustion) in 1963 in Germany to that in Greece?
Give a very brief answer. 8.32. What is the ratio of the CO2 emissions (% of total fuel combustion) in 1960 in Germany to that in Iceland?
Make the answer very short. 0.17. What is the ratio of the CO2 emissions (% of total fuel combustion) in 1961 in Germany to that in Iceland?
Your response must be concise. 0.2. What is the ratio of the CO2 emissions (% of total fuel combustion) in 1962 in Germany to that in Iceland?
Provide a short and direct response. 0.19. What is the ratio of the CO2 emissions (% of total fuel combustion) of 1963 in Germany to that in Iceland?
Make the answer very short. 0.23. What is the ratio of the CO2 emissions (% of total fuel combustion) of 1960 in Greece to that in Iceland?
Provide a succinct answer. 0.03. What is the ratio of the CO2 emissions (% of total fuel combustion) of 1961 in Greece to that in Iceland?
Offer a very short reply. 0.03. What is the ratio of the CO2 emissions (% of total fuel combustion) in 1962 in Greece to that in Iceland?
Your answer should be very brief. 0.02. What is the ratio of the CO2 emissions (% of total fuel combustion) of 1963 in Greece to that in Iceland?
Make the answer very short. 0.03. What is the difference between the highest and the second highest CO2 emissions (% of total fuel combustion) in 1960?
Make the answer very short. 27.08. What is the difference between the highest and the second highest CO2 emissions (% of total fuel combustion) in 1961?
Provide a short and direct response. 18.97. What is the difference between the highest and the second highest CO2 emissions (% of total fuel combustion) in 1962?
Your answer should be compact. 25.23. What is the difference between the highest and the second highest CO2 emissions (% of total fuel combustion) in 1963?
Make the answer very short. 23.95. What is the difference between the highest and the lowest CO2 emissions (% of total fuel combustion) in 1960?
Your answer should be very brief. 32.7. What is the difference between the highest and the lowest CO2 emissions (% of total fuel combustion) of 1961?
Make the answer very short. 25.46. What is the difference between the highest and the lowest CO2 emissions (% of total fuel combustion) in 1962?
Your answer should be compact. 31.73. What is the difference between the highest and the lowest CO2 emissions (% of total fuel combustion) in 1963?
Offer a terse response. 30.11. 